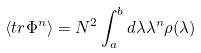Convert formula to latex. <formula><loc_0><loc_0><loc_500><loc_500>\langle t r \Phi ^ { n } \rangle = N ^ { 2 } \int _ { a } ^ { b } d \lambda \lambda ^ { n } \rho ( \lambda )</formula> 